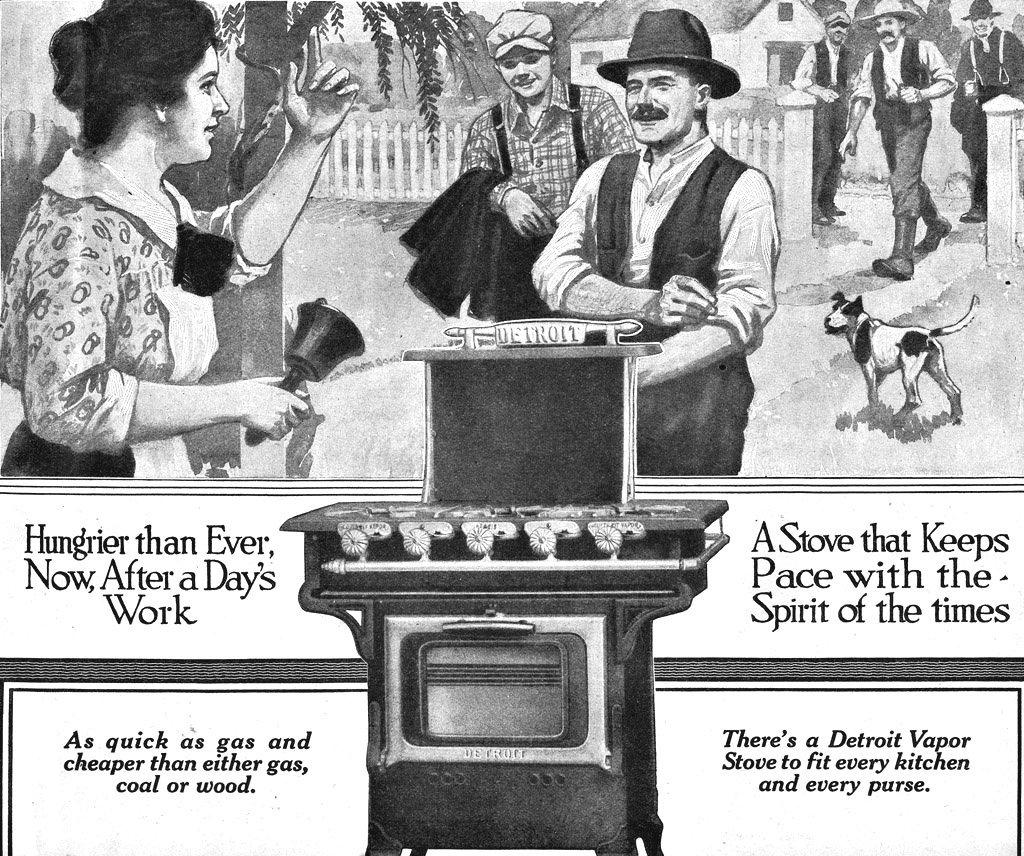<image>
Offer a succinct explanation of the picture presented. an ad for a stove, that says it is as quick as gas 